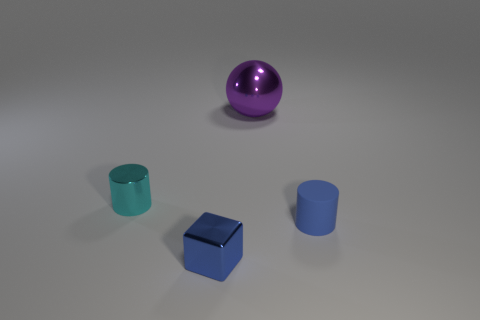What material is the cyan cylinder that is the same size as the cube?
Provide a succinct answer. Metal. What color is the small cylinder left of the metal object behind the cyan cylinder?
Offer a very short reply. Cyan. What number of purple metal spheres are in front of the blue cube?
Keep it short and to the point. 0. The tiny block has what color?
Provide a succinct answer. Blue. What number of small things are blue cylinders or cyan metallic cylinders?
Offer a terse response. 2. Does the cylinder to the left of the purple metallic sphere have the same color as the metallic object that is behind the cyan metal cylinder?
Your answer should be compact. No. How many other things are the same color as the ball?
Make the answer very short. 0. There is a tiny shiny object that is right of the tiny cyan metallic object; what is its shape?
Ensure brevity in your answer.  Cube. Is the number of tiny blue cubes less than the number of cyan rubber cylinders?
Give a very brief answer. No. Are the cylinder that is to the right of the blue shiny block and the tiny blue cube made of the same material?
Keep it short and to the point. No. 